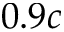<formula> <loc_0><loc_0><loc_500><loc_500>0 . 9 c</formula> 